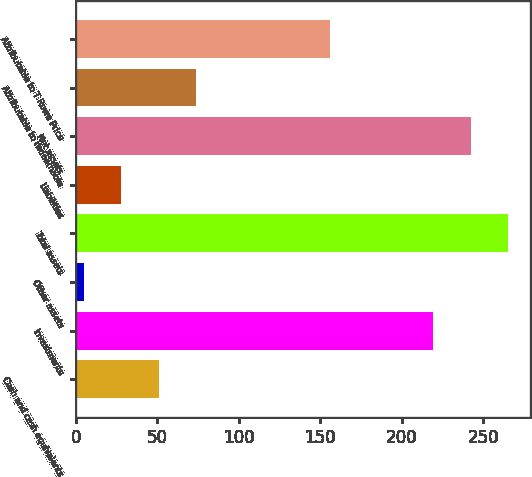Convert chart. <chart><loc_0><loc_0><loc_500><loc_500><bar_chart><fcel>Cash and cash equivalents<fcel>Investments<fcel>Other assets<fcel>Total assets<fcel>Liabilities<fcel>Net assets<fcel>Attributable to redeemable<fcel>Attributable to T Rowe Price<nl><fcel>50.72<fcel>219.3<fcel>4.8<fcel>265.22<fcel>27.76<fcel>242.26<fcel>73.68<fcel>156.1<nl></chart> 